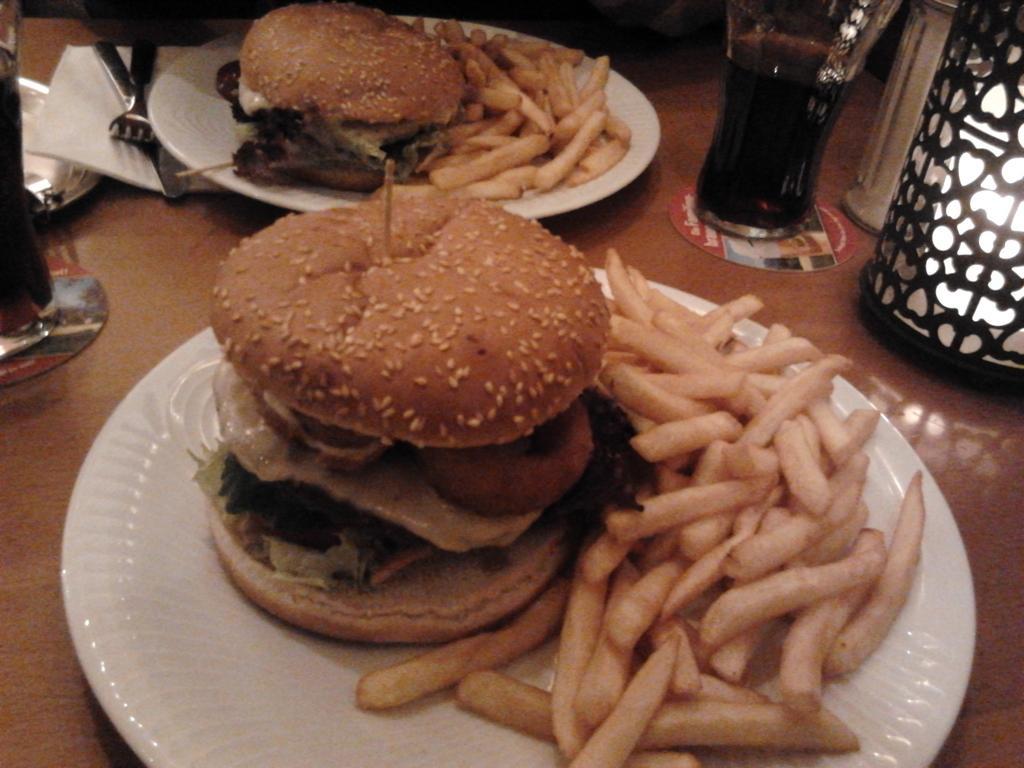How would you summarize this image in a sentence or two? This image consists of burgers and french fries kept on the plates. On the left and right, we can see the drinks in the glasses. At the bottom, there is a table. On the right, it looks like a lamp. And we can see the forks along with the tissues. 